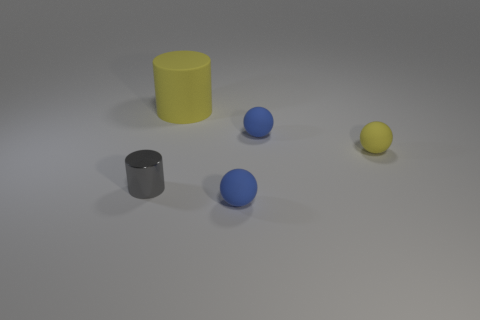How many objects are either gray cylinders or tiny rubber objects behind the small gray metallic object?
Your response must be concise. 3. What number of objects are either cylinders in front of the big yellow object or matte things that are to the right of the big yellow thing?
Give a very brief answer. 4. There is a big matte object; are there any small blue objects behind it?
Ensure brevity in your answer.  No. What is the color of the matte thing that is right of the tiny blue rubber sphere that is behind the blue rubber sphere in front of the gray object?
Keep it short and to the point. Yellow. Do the large thing and the gray metal thing have the same shape?
Offer a terse response. Yes. How many objects are small blue things behind the small metal cylinder or small spheres?
Ensure brevity in your answer.  3. What is the size of the yellow thing that is to the right of the big thing?
Keep it short and to the point. Small. Do the gray object and the yellow rubber thing that is in front of the big matte object have the same size?
Make the answer very short. Yes. There is a ball in front of the cylinder that is in front of the large yellow rubber cylinder; what is its color?
Your answer should be very brief. Blue. How many other objects are there of the same color as the large cylinder?
Your answer should be very brief. 1. 